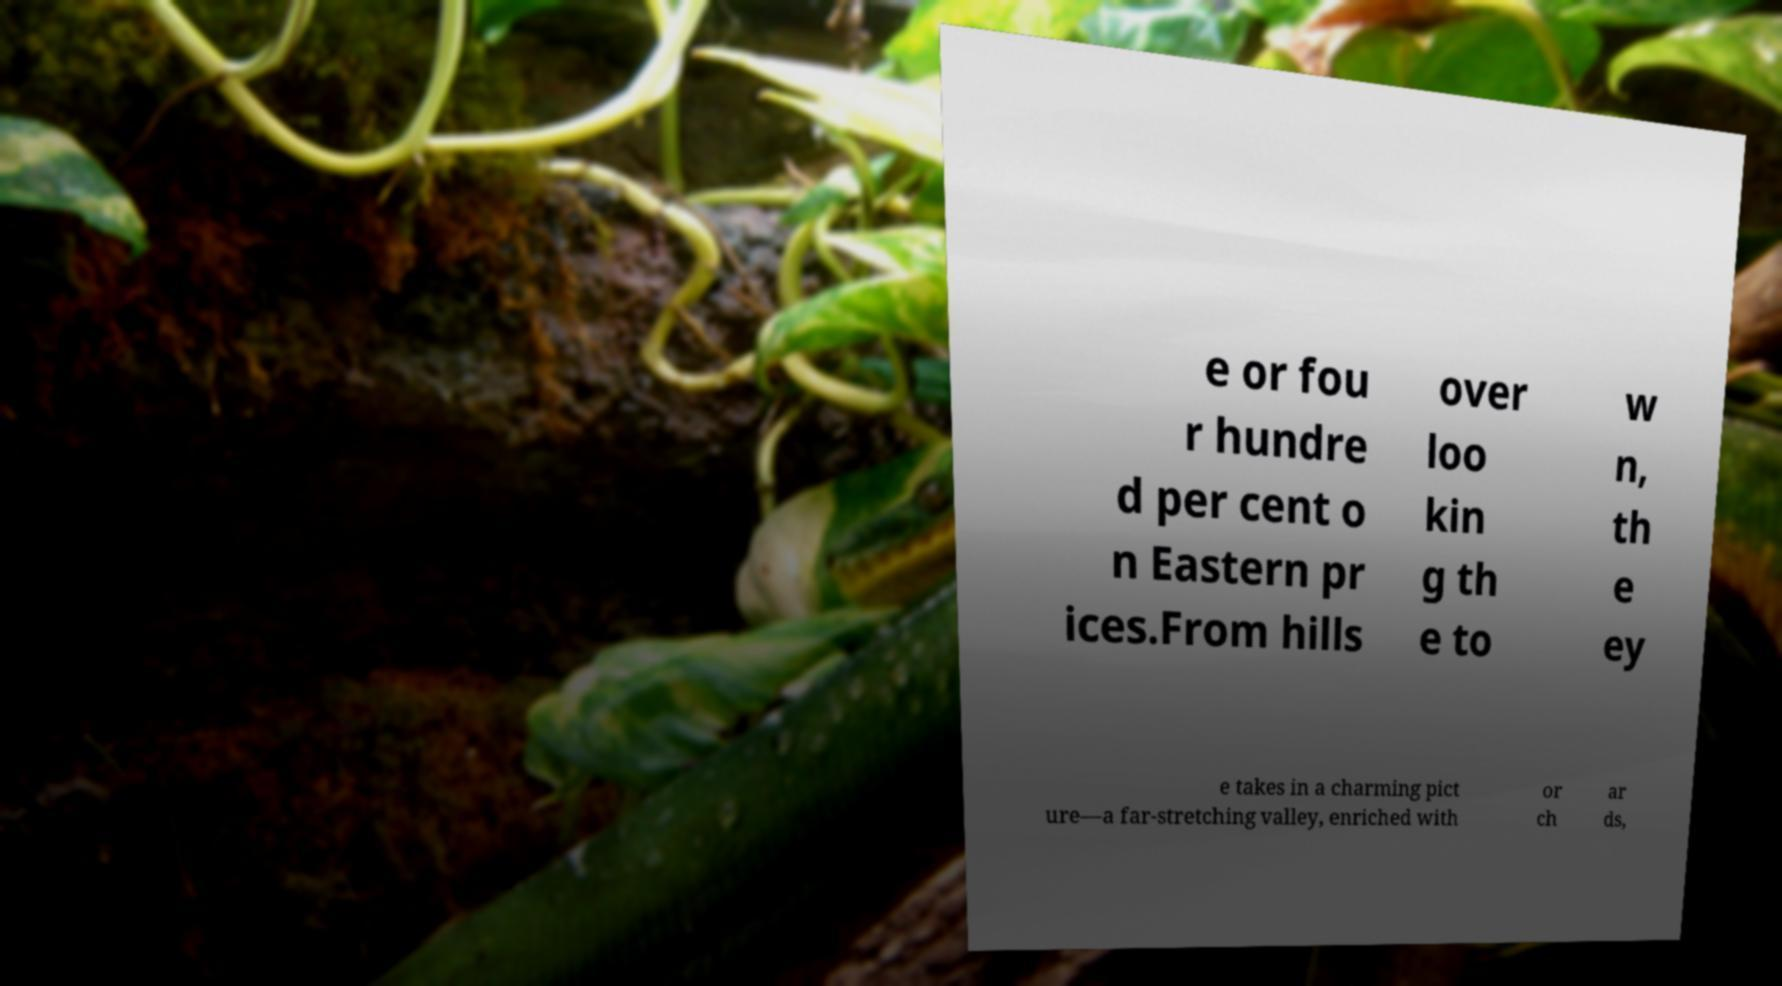I need the written content from this picture converted into text. Can you do that? e or fou r hundre d per cent o n Eastern pr ices.From hills over loo kin g th e to w n, th e ey e takes in a charming pict ure—a far-stretching valley, enriched with or ch ar ds, 